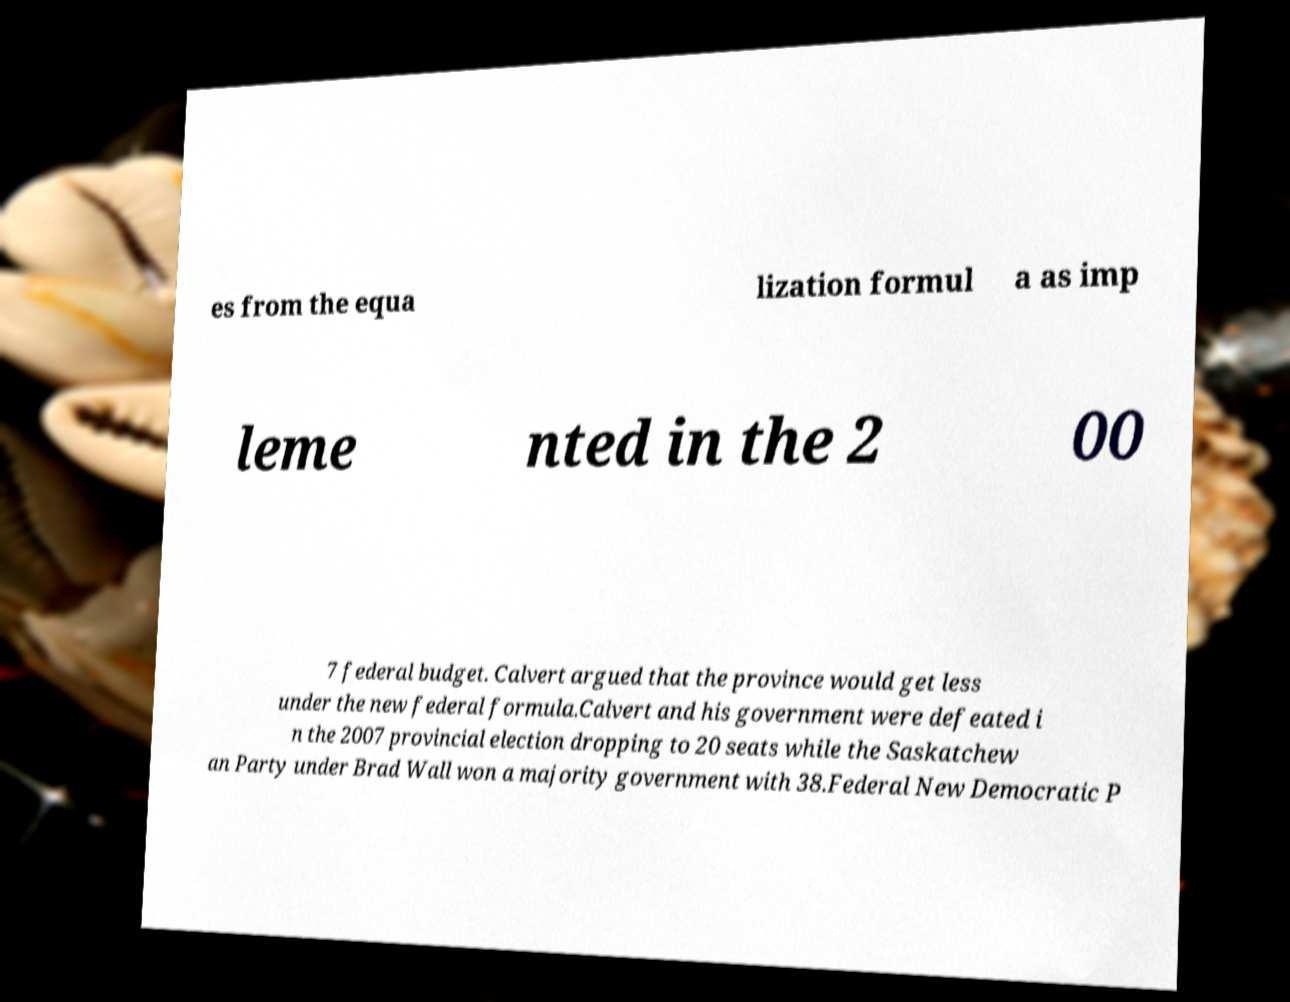I need the written content from this picture converted into text. Can you do that? es from the equa lization formul a as imp leme nted in the 2 00 7 federal budget. Calvert argued that the province would get less under the new federal formula.Calvert and his government were defeated i n the 2007 provincial election dropping to 20 seats while the Saskatchew an Party under Brad Wall won a majority government with 38.Federal New Democratic P 